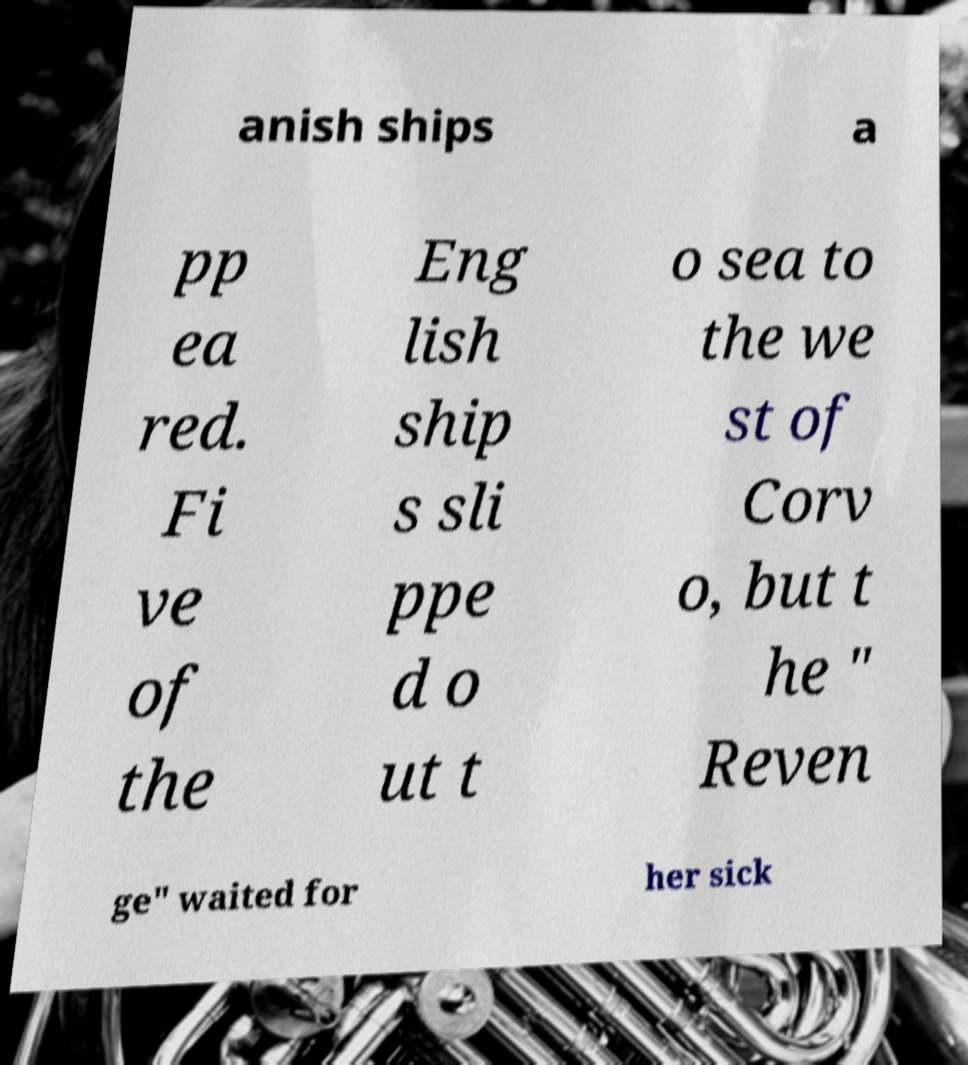For documentation purposes, I need the text within this image transcribed. Could you provide that? anish ships a pp ea red. Fi ve of the Eng lish ship s sli ppe d o ut t o sea to the we st of Corv o, but t he " Reven ge" waited for her sick 